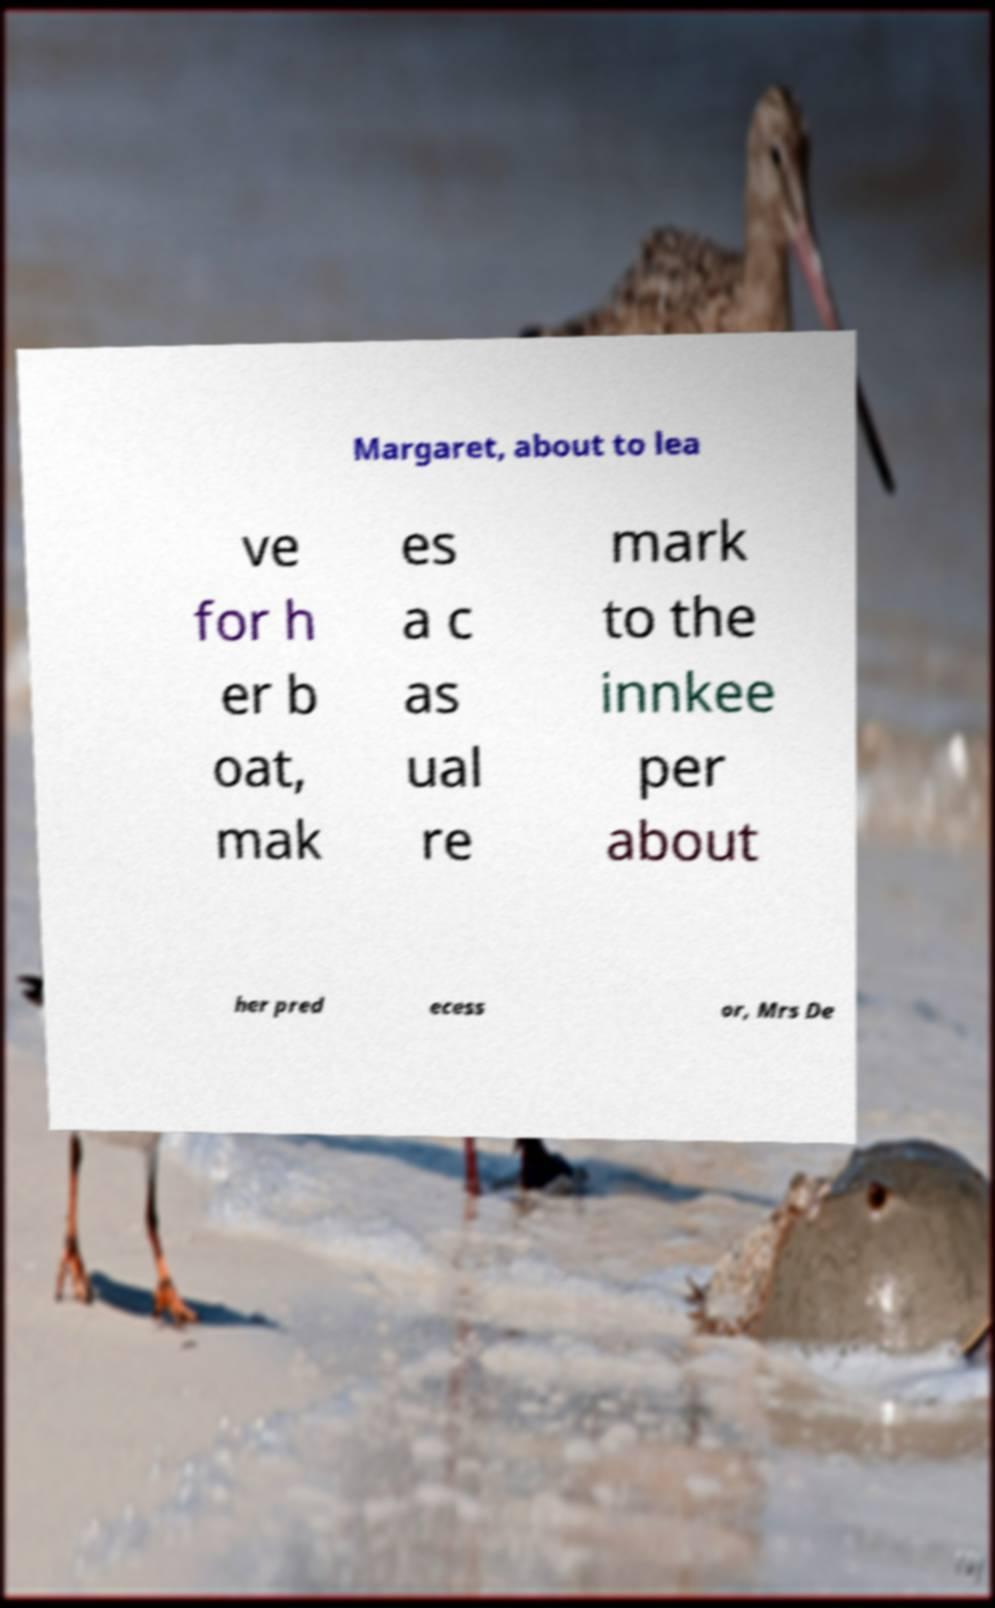What messages or text are displayed in this image? I need them in a readable, typed format. Margaret, about to lea ve for h er b oat, mak es a c as ual re mark to the innkee per about her pred ecess or, Mrs De 